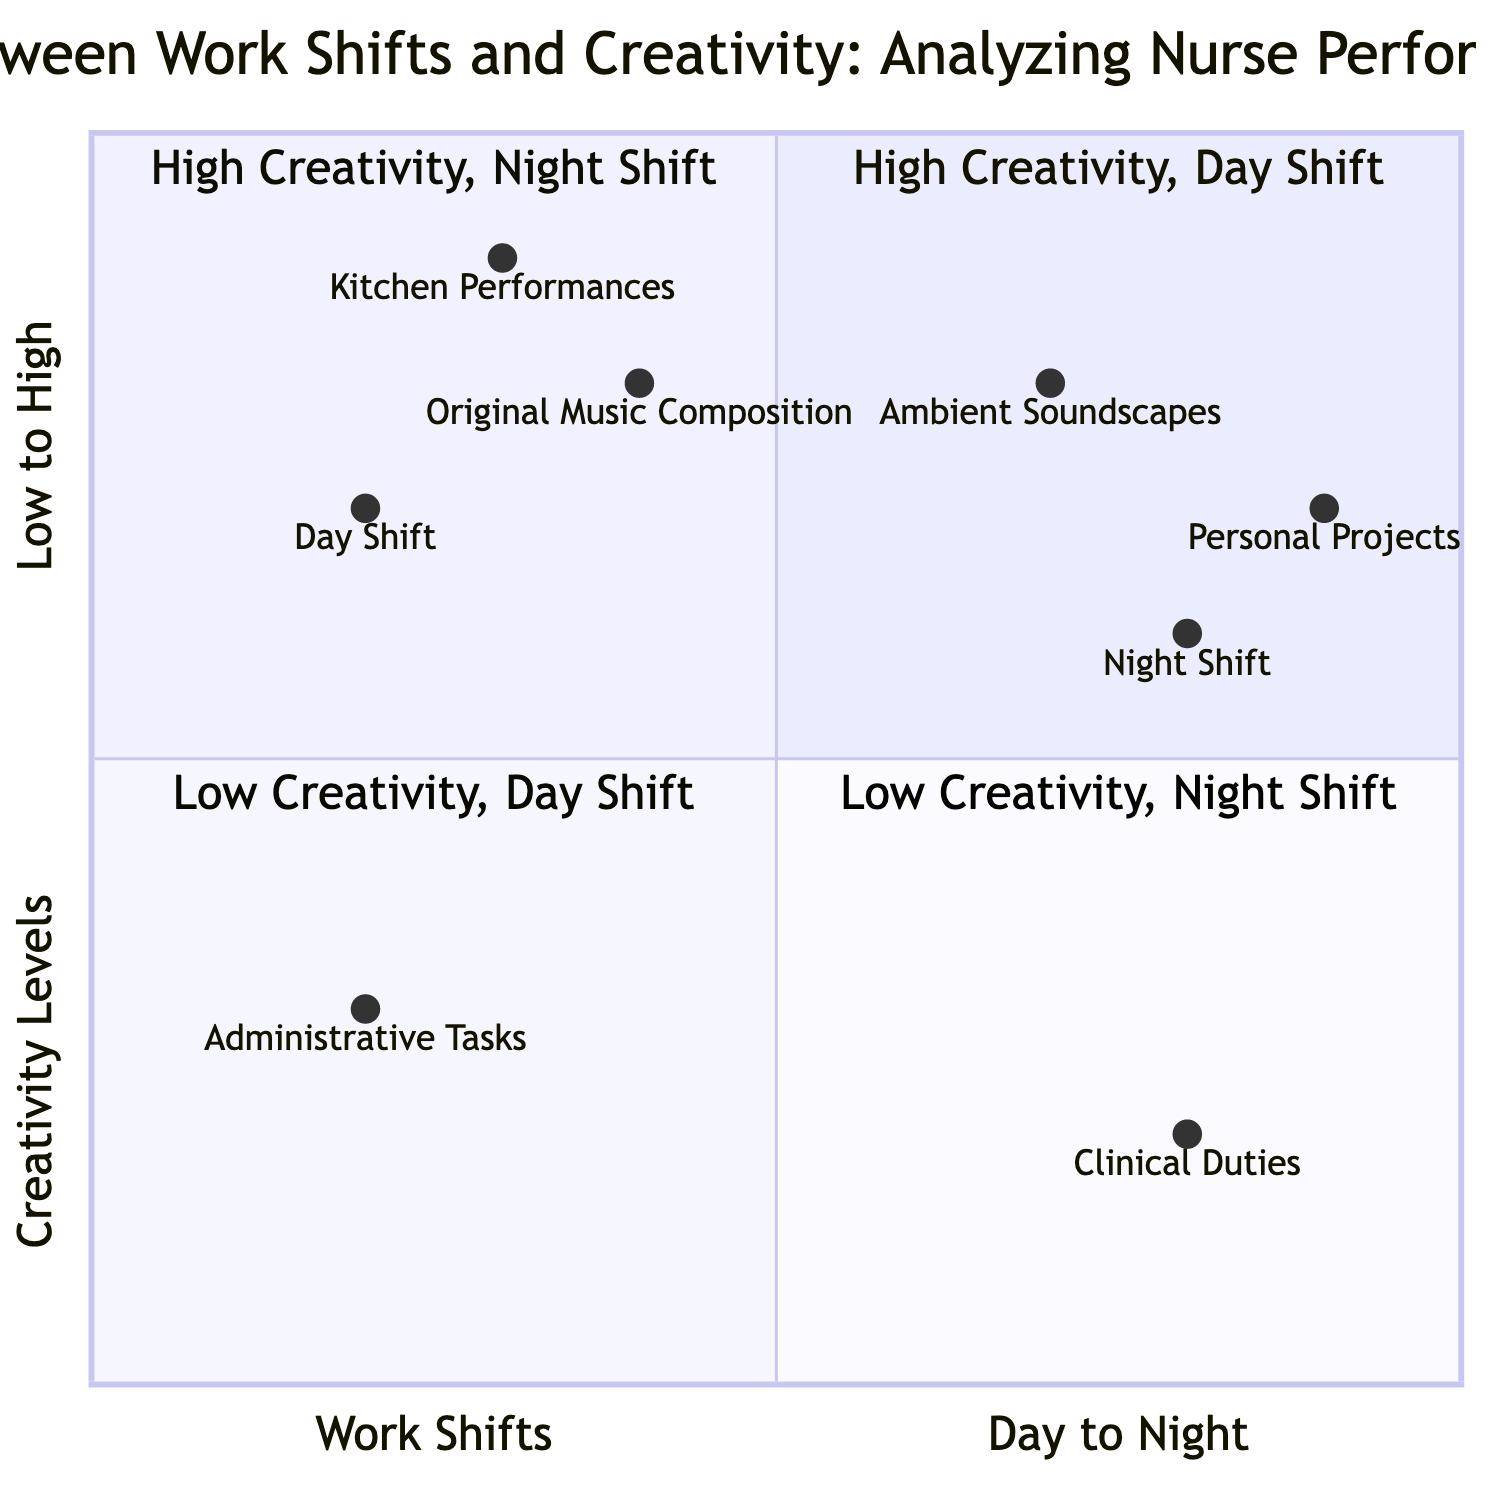What is the name of Quadrant 1? Quadrant 1 is labeled "High Creativity, Day Shift". This can be found in the top-left section of the quadrant chart where high creativity levels are associated with day shifts.
Answer: High Creativity, Day Shift Which quadrant describes nurses who focus on essential clinical duties? This description applies to Quadrant 4, labeled "Low Creativity, Night Shift." It is in the bottom-right section, indicating low creativity levels during night shifts.
Answer: Low Creativity, Night Shift How many different examples are provided for Quadrant 2? Quadrant 2, which is "High Creativity, Night Shift," has two examples listed. By counting the items in the examples section, we confirm there are two.
Answer: 2 What is the creativity level for nurses working on personal music projects? Personal music projects fall under Quadrant 2, indicating that nurses working on these projects have high creativity levels, which can also be seen in the y-axis.
Answer: High Which work shift shows minimal involvement in musical activities? This scenario falls under Quadrant 3, known as "Low Creativity, Day Shift." It indicates low creativity during day shifts, specifically highlighting minimal musical involvement.
Answer: Day Shift What example is given for nurses exhibiting high creativity during night shifts? One example provided for high creativity during night shifts is "Producing ambient soundscapes after hours." This can be found in the metadata section of Quadrant 2.
Answer: Producing ambient soundscapes after hours Where are the creative kitchen performances located in the diagram? Creative kitchen performances are associated with Quadrant 1, labeled "High Creativity, Day Shift." This quadrant represents high creativity levels during day shifts, where such performances might happen.
Answer: High Creativity, Day Shift Which quadrant has fatigue impacting creative output? Fatigue affecting creative output is described in Quadrant 4, labeled "Low Creativity, Night Shift." This indicates challenges to creativity during night shifts due to fatigue.
Answer: Low Creativity, Night Shift 